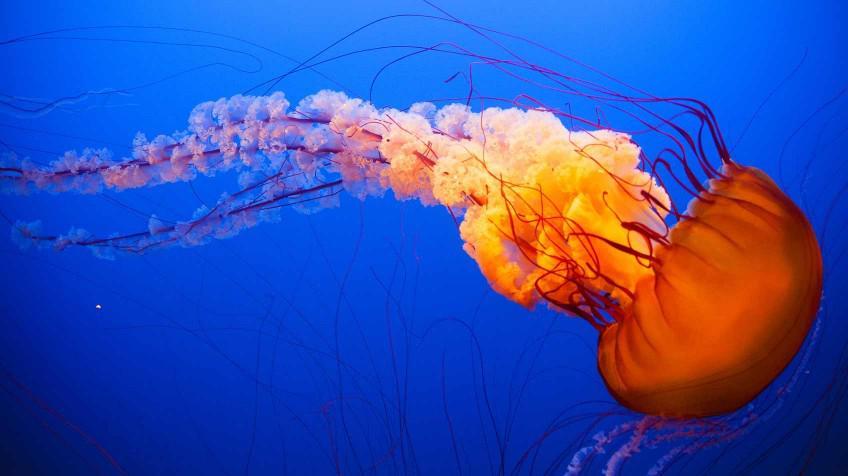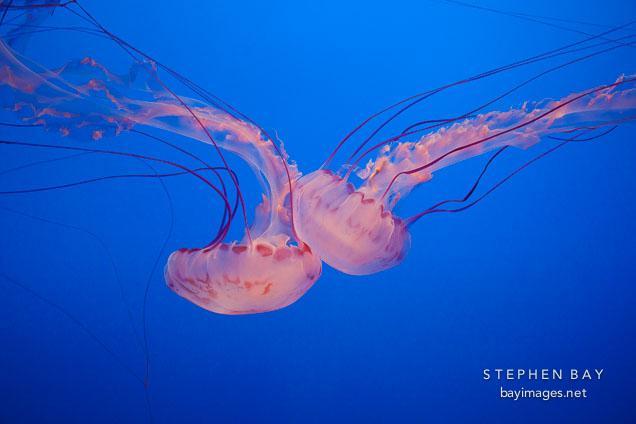The first image is the image on the left, the second image is the image on the right. Analyze the images presented: Is the assertion "There are three jellyfish in total." valid? Answer yes or no. Yes. 